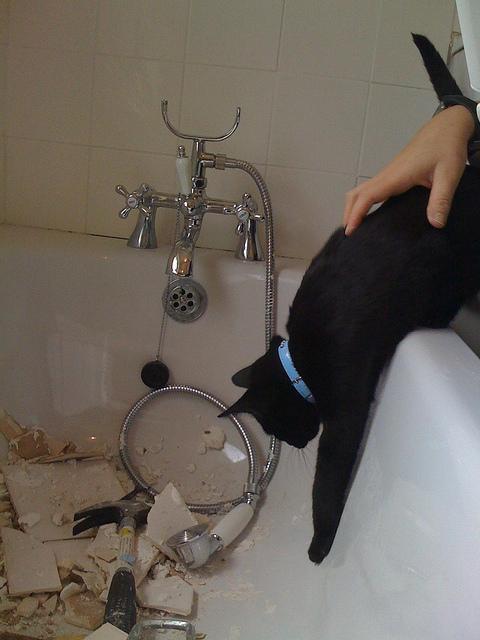How many thumbs are visible?
Give a very brief answer. 1. How many of the train cars are yellow and red?
Give a very brief answer. 0. 